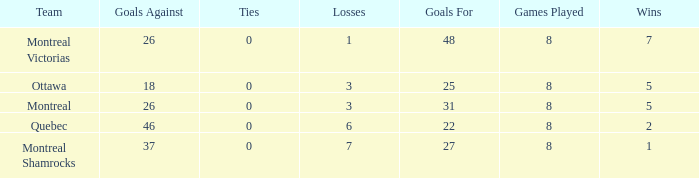For teams with fewer than 5 wins, goals against over 37, and fewer than 8 games played, what is the average number of ties? None. 